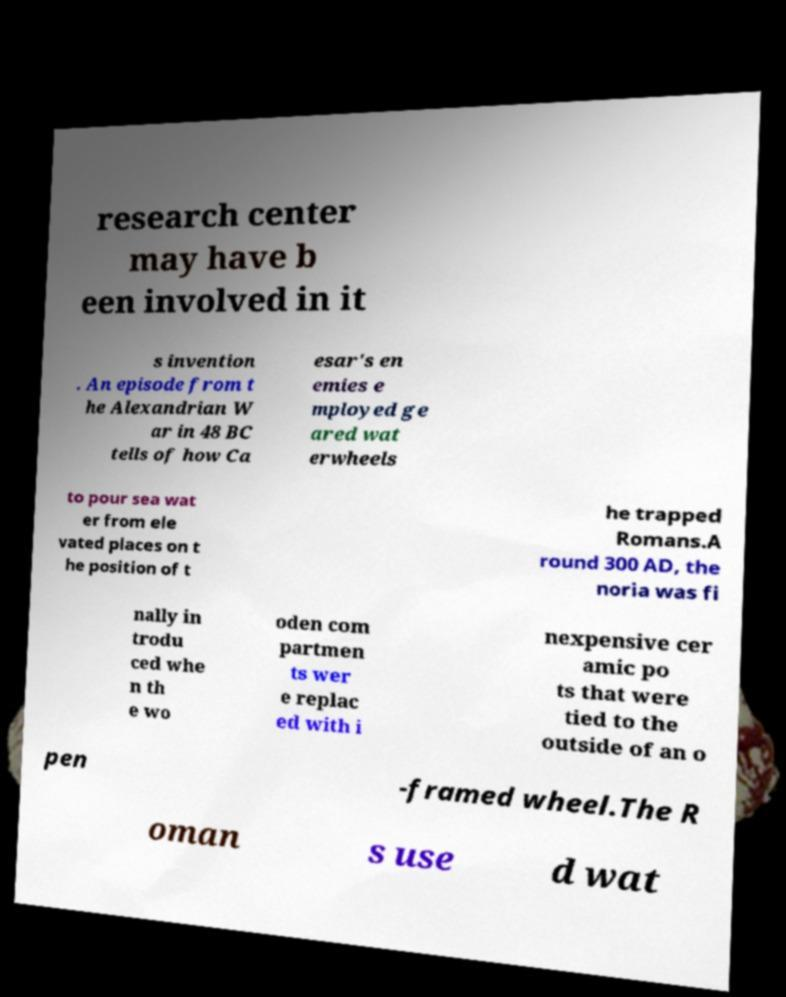Please read and relay the text visible in this image. What does it say? research center may have b een involved in it s invention . An episode from t he Alexandrian W ar in 48 BC tells of how Ca esar's en emies e mployed ge ared wat erwheels to pour sea wat er from ele vated places on t he position of t he trapped Romans.A round 300 AD, the noria was fi nally in trodu ced whe n th e wo oden com partmen ts wer e replac ed with i nexpensive cer amic po ts that were tied to the outside of an o pen -framed wheel.The R oman s use d wat 